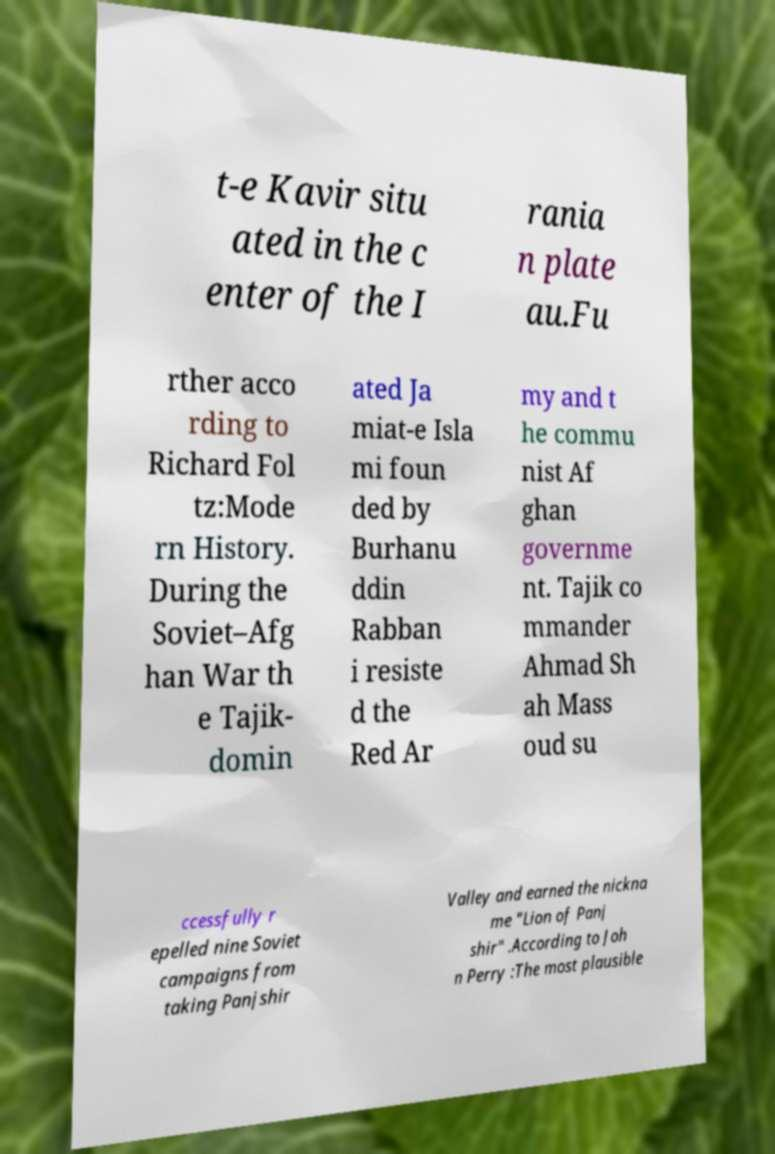Can you read and provide the text displayed in the image?This photo seems to have some interesting text. Can you extract and type it out for me? t-e Kavir situ ated in the c enter of the I rania n plate au.Fu rther acco rding to Richard Fol tz:Mode rn History. During the Soviet–Afg han War th e Tajik- domin ated Ja miat-e Isla mi foun ded by Burhanu ddin Rabban i resiste d the Red Ar my and t he commu nist Af ghan governme nt. Tajik co mmander Ahmad Sh ah Mass oud su ccessfully r epelled nine Soviet campaigns from taking Panjshir Valley and earned the nickna me "Lion of Panj shir" .According to Joh n Perry :The most plausible 